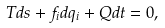<formula> <loc_0><loc_0><loc_500><loc_500>T d s + f _ { i } d q _ { i } + Q d t = 0 ,</formula> 